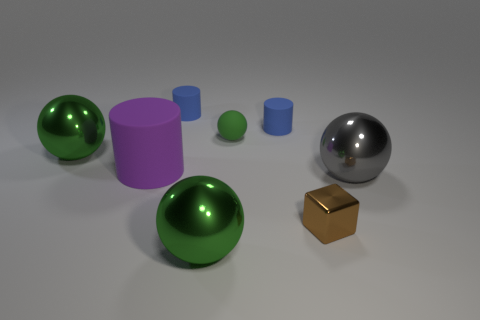Subtract all green spheres. How many were subtracted if there are1green spheres left? 2 Subtract all green blocks. How many blue cylinders are left? 2 Add 1 tiny brown shiny objects. How many objects exist? 9 Subtract all tiny green matte spheres. How many spheres are left? 3 Subtract all gray spheres. How many spheres are left? 3 Subtract 1 cylinders. How many cylinders are left? 2 Subtract all cubes. How many objects are left? 7 Subtract all yellow spheres. Subtract all green blocks. How many spheres are left? 4 Subtract 0 gray blocks. How many objects are left? 8 Subtract all big blue matte blocks. Subtract all big green balls. How many objects are left? 6 